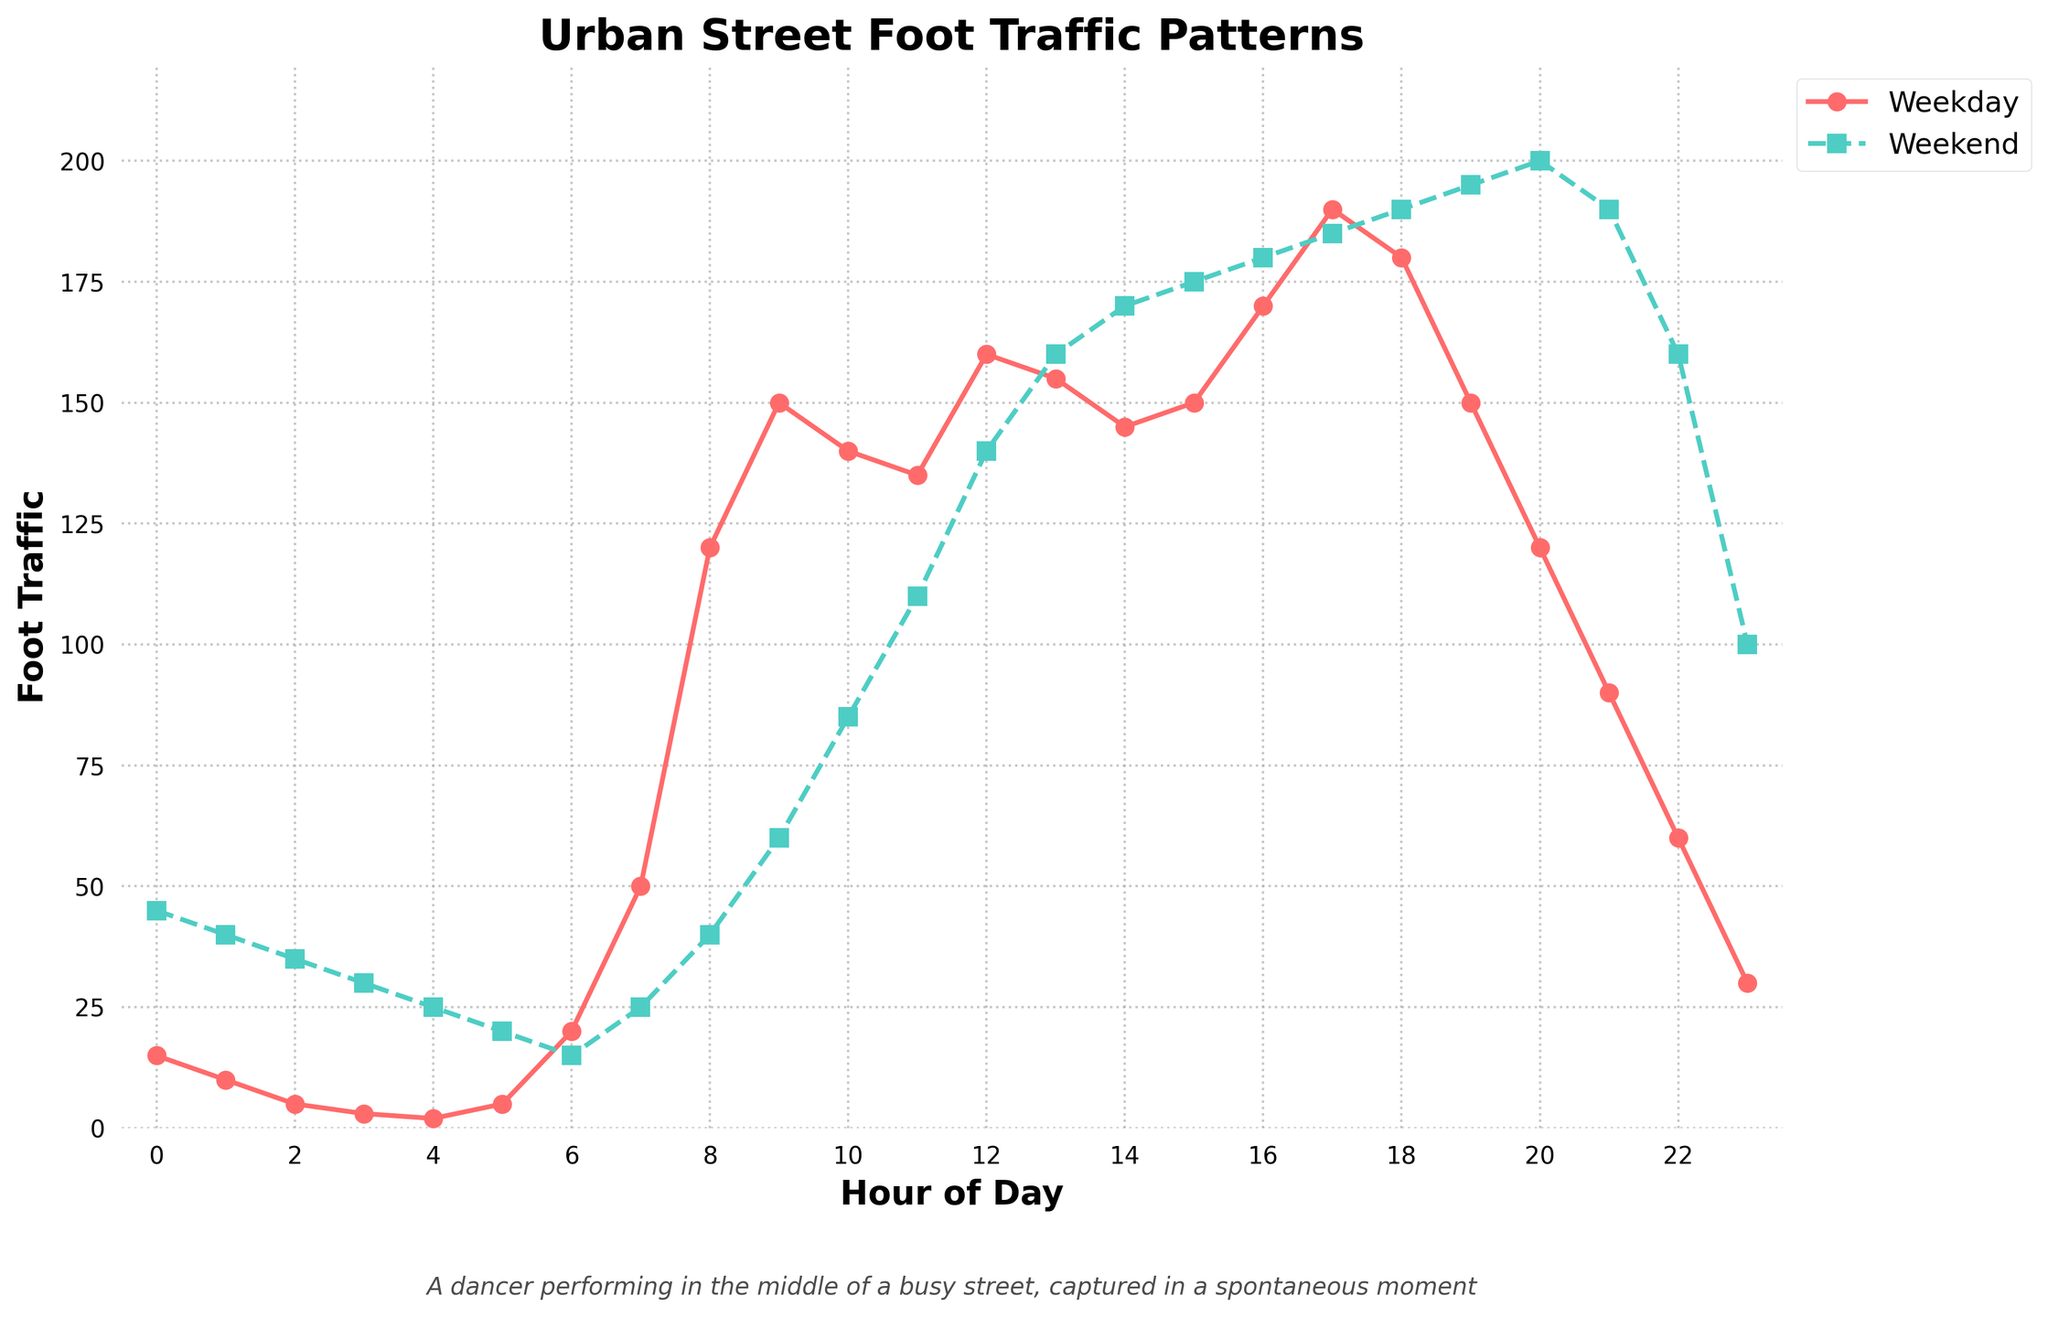What’s the difference in foot traffic between weekdays and weekends at 8 AM? At 8 AM, the weekday traffic is 120 and the weekend traffic is 40. The difference is calculated as 120 - 40.
Answer: 80 When does the weekday foot traffic peak, and what is the value? The weekday foot traffic peaks at 12 PM with a value of 160, as seen from the highest point on the weekday line.
Answer: 12 PM, 160 Which time period has the greatest difference in foot traffic between weekdays and weekends? The greatest difference is at 0 AM. The weekday traffic is 15 and the weekend traffic is 45. The difference is 45 - 15 = 30.
Answer: 0 AM What is the median foot traffic for weekends from 9 AM to 5 PM? The weekend traffic values from 9 AM to 5 PM are 60, 85, 110, 140, 160, 170, 175, 180, and 185. Arranging them in order, the median is the middle value, which is 160.
Answer: 160 Compare the foot traffic at 6 AM between weekdays and weekends. Which is higher? At 6 AM, weekday traffic is 20 and weekend traffic is 15. Therefore, weekday foot traffic is higher.
Answer: Weekday How does the foot traffic trend change during the evening hours (6 PM to 10 PM) for weekends? The foot traffic during weekends increases from 190 at 6 PM to 200 at 8 PM, then decreases to 190 at 9 PM and further to 160 at 10 PM.
Answer: Increases then decreases At what times do both weekdays and weekends have exactly 150 foot traffic? Both have 150 foot traffic at 9 AM (weekdays) and 7 PM (weekends). The weekday traffic is exactly 150 at 9 AM. The weekend traffic is exactly 150 at 7 PM.
Answer: 9 AM (weekdays), 7 PM (weekends) What is the average foot traffic on weekdays between 7 AM and 10 AM? The weekday traffic values between 7 AM and 10 AM are 50, 120, 150, 140. The average is calculated by (50 + 120 + 150 + 140) / 4 = 115.
Answer: 115 What time has the least foot traffic on weekdays, and what is the value? The least foot traffic on weekdays occurs at 4 AM with a value of 2, as shown by the lowest point on the weekday line.
Answer: 4 AM, 2 